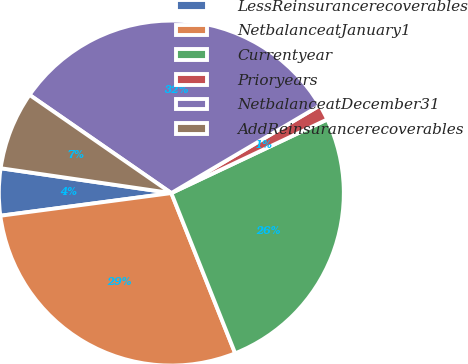Convert chart to OTSL. <chart><loc_0><loc_0><loc_500><loc_500><pie_chart><fcel>LessReinsurancerecoverables<fcel>NetbalanceatJanuary1<fcel>Currentyear<fcel>Prioryears<fcel>NetbalanceatDecember31<fcel>AddReinsurancerecoverables<nl><fcel>4.4%<fcel>28.94%<fcel>25.99%<fcel>1.46%<fcel>31.88%<fcel>7.34%<nl></chart> 